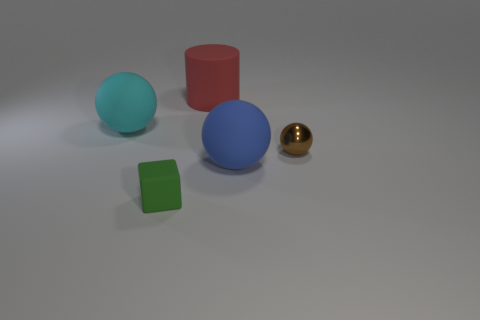Are there fewer cyan matte objects than big green cylinders?
Provide a short and direct response. No. What number of things are big yellow shiny balls or small cubes?
Offer a very short reply. 1. Is the small brown thing the same shape as the blue rubber thing?
Offer a very short reply. Yes. Is there anything else that is the same material as the small ball?
Ensure brevity in your answer.  No. There is a rubber ball that is on the left side of the red matte cylinder; is its size the same as the rubber block that is in front of the large cylinder?
Ensure brevity in your answer.  No. What is the material of the thing that is both behind the brown thing and in front of the red matte thing?
Make the answer very short. Rubber. Are there any other things that are the same color as the cylinder?
Your response must be concise. No. Is the number of brown shiny things left of the blue matte thing less than the number of brown shiny blocks?
Your response must be concise. No. Are there more tiny brown cylinders than big cyan objects?
Your answer should be very brief. No. Is there a brown shiny ball left of the large rubber ball to the right of the big matte thing that is behind the big cyan object?
Provide a short and direct response. No. 